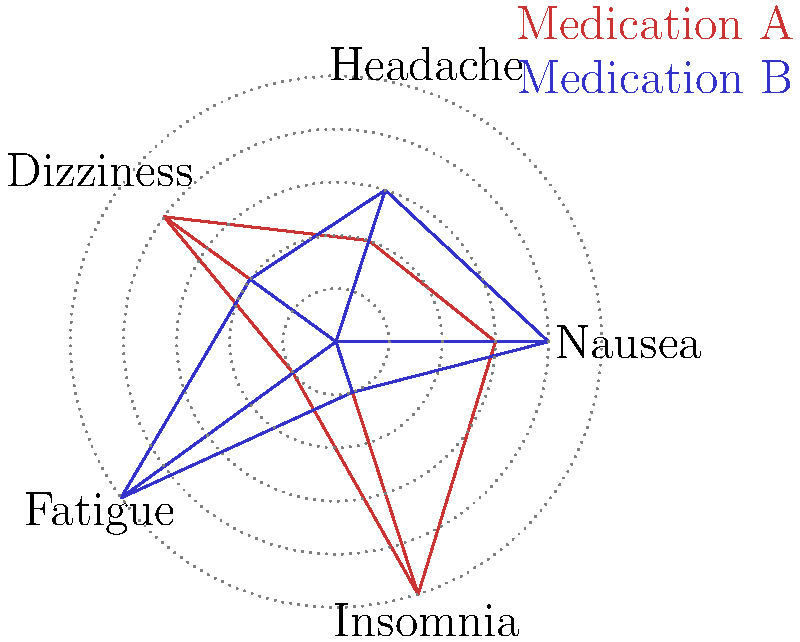Based on the vector radar chart comparing side effect profiles of Medication A and Medication B, which medication is more likely to cause fatigue in your loved one? To answer this question, we need to analyze the vector radar chart:

1. Identify the axis for fatigue:
   The chart has 5 axes, each representing a side effect. The "Fatigue" axis is located on the right side of the chart.

2. Compare the values for Medication A and Medication B on the fatigue axis:
   - Medication A (red): The line extends to the 1st concentric circle from the center.
   - Medication B (blue): The line extends to the 5th (outermost) concentric circle.

3. Interpret the chart:
   In this type of chart, a longer line indicates a higher likelihood or severity of the side effect.

4. Draw a conclusion:
   Since Medication B's line extends much further on the fatigue axis compared to Medication A, it indicates that Medication B is more likely to cause fatigue.

Therefore, based on the information provided in the vector radar chart, Medication B is more likely to cause fatigue in your loved one.
Answer: Medication B 